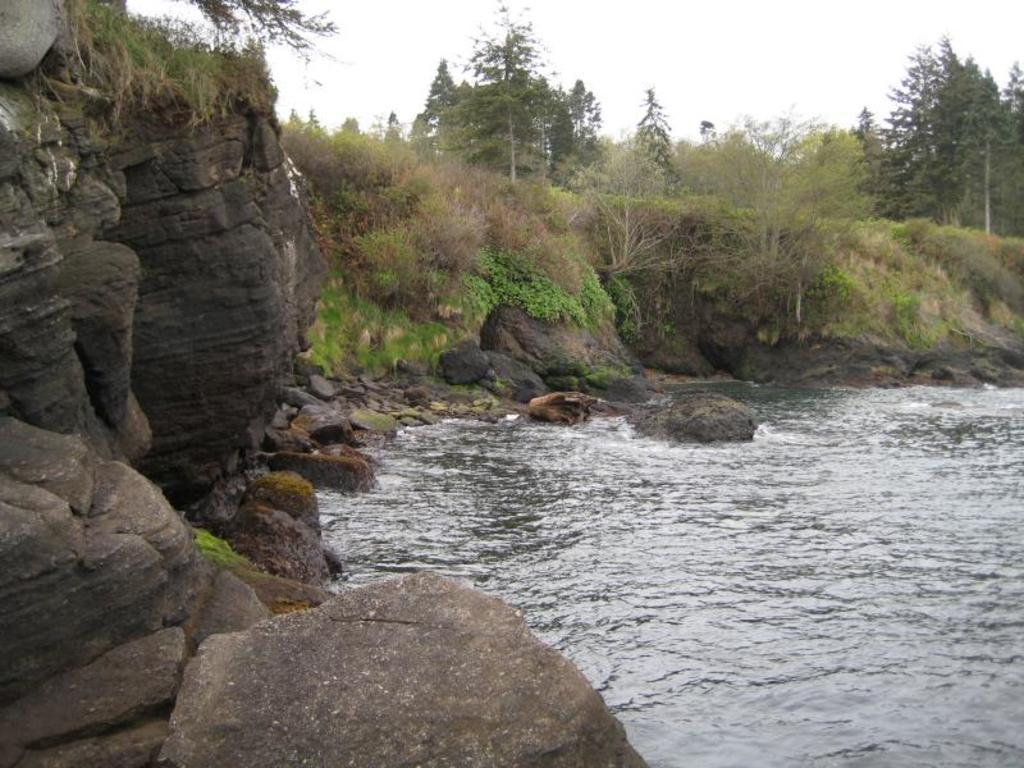What type of natural feature is present in the image? There is a water body in the image. What other elements can be seen in the image? Stones, plants, and a group of trees are visible in the image. How would you describe the sky in the image? The sky is visible in the image and appears cloudy. What type of property is being sold in the image? There is no indication of a property being sold in the image. Can you see a head in the image? There is no head visible in the image. 